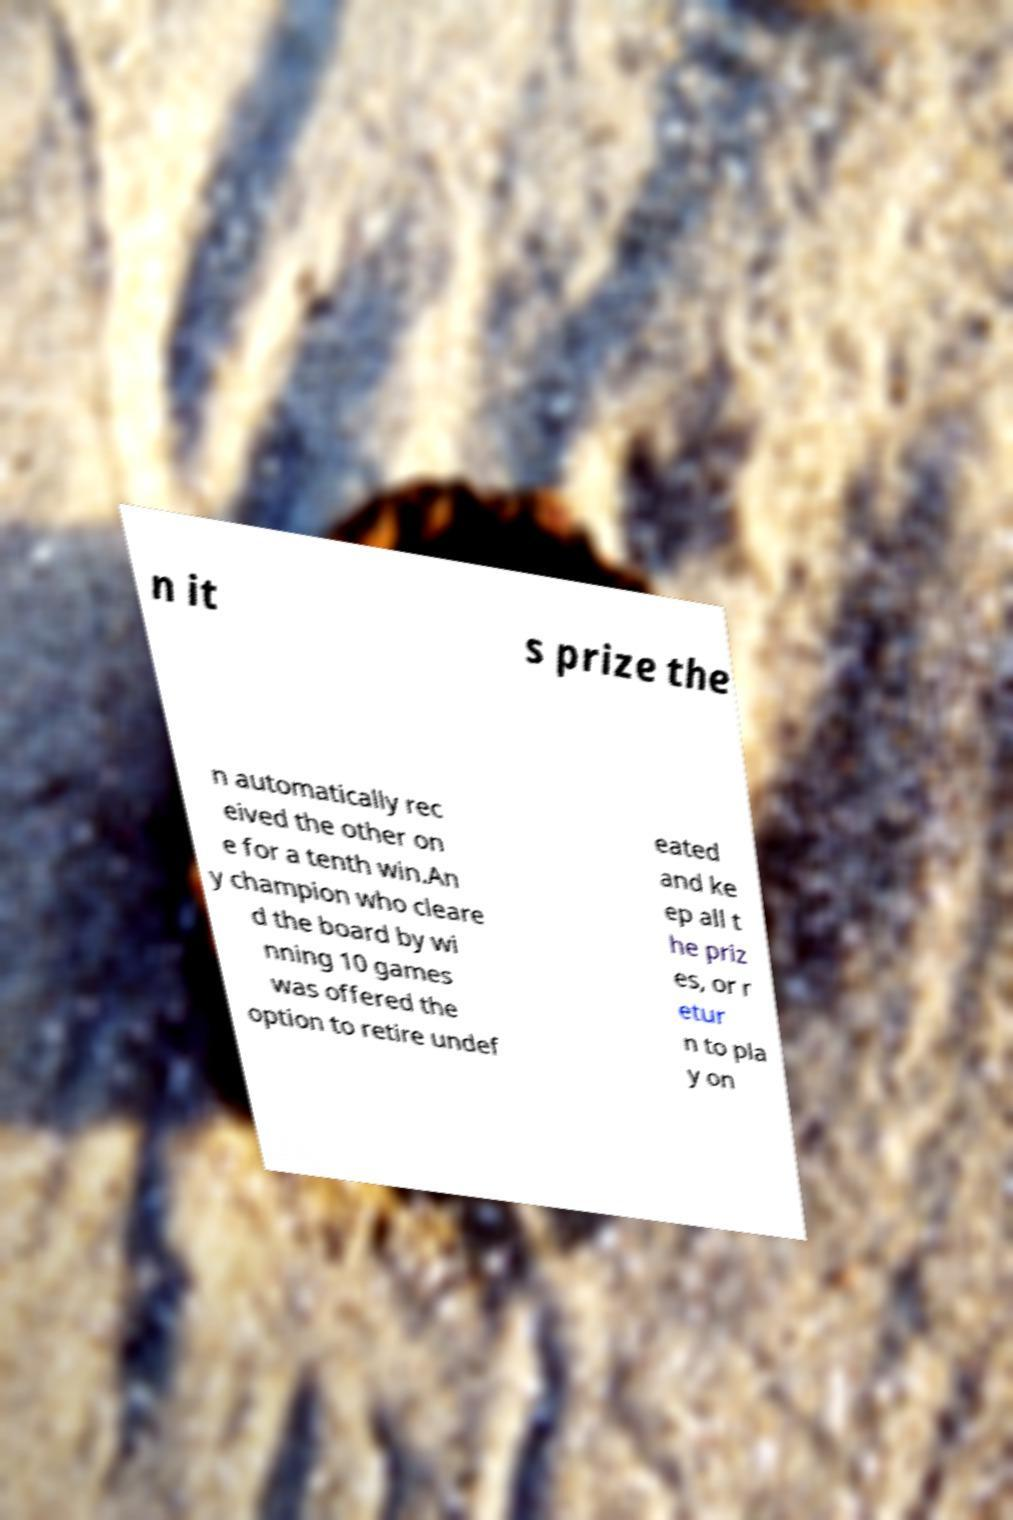For documentation purposes, I need the text within this image transcribed. Could you provide that? n it s prize the n automatically rec eived the other on e for a tenth win.An y champion who cleare d the board by wi nning 10 games was offered the option to retire undef eated and ke ep all t he priz es, or r etur n to pla y on 